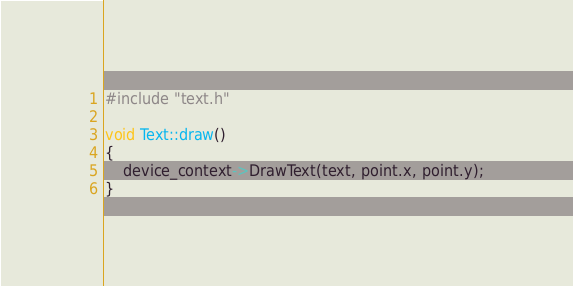Convert code to text. <code><loc_0><loc_0><loc_500><loc_500><_C++_>#include "text.h"

void Text::draw() 
{
	device_context->DrawText(text, point.x, point.y);
}</code> 